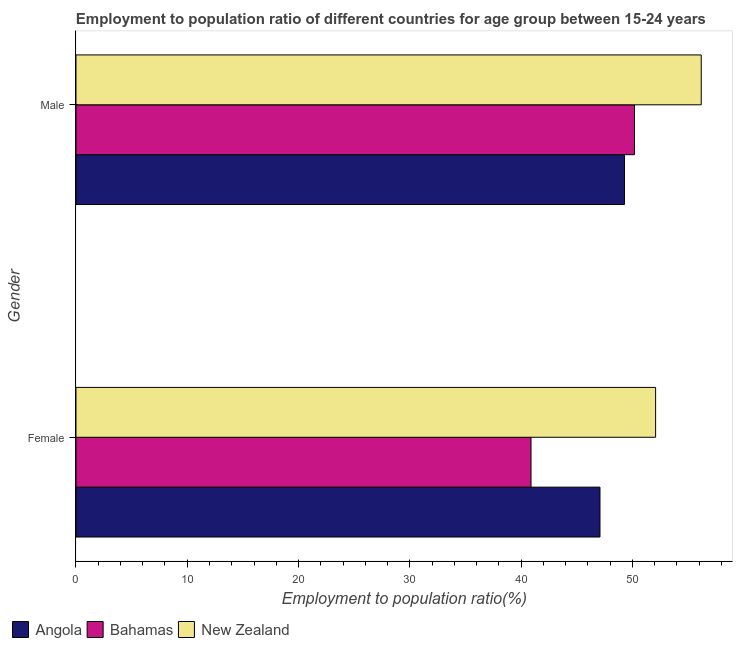How many different coloured bars are there?
Provide a succinct answer. 3. How many groups of bars are there?
Give a very brief answer. 2. How many bars are there on the 2nd tick from the bottom?
Make the answer very short. 3. What is the employment to population ratio(female) in Angola?
Give a very brief answer. 47.1. Across all countries, what is the maximum employment to population ratio(female)?
Ensure brevity in your answer.  52.1. Across all countries, what is the minimum employment to population ratio(female)?
Make the answer very short. 40.9. In which country was the employment to population ratio(female) maximum?
Your answer should be very brief. New Zealand. In which country was the employment to population ratio(male) minimum?
Keep it short and to the point. Angola. What is the total employment to population ratio(male) in the graph?
Make the answer very short. 155.7. What is the difference between the employment to population ratio(male) in New Zealand and the employment to population ratio(female) in Bahamas?
Offer a very short reply. 15.3. What is the average employment to population ratio(female) per country?
Your response must be concise. 46.7. What is the difference between the employment to population ratio(female) and employment to population ratio(male) in New Zealand?
Provide a succinct answer. -4.1. What is the ratio of the employment to population ratio(male) in Bahamas to that in New Zealand?
Offer a terse response. 0.89. Is the employment to population ratio(male) in Bahamas less than that in Angola?
Offer a terse response. No. What does the 3rd bar from the top in Female represents?
Ensure brevity in your answer.  Angola. What does the 1st bar from the bottom in Female represents?
Offer a terse response. Angola. Are all the bars in the graph horizontal?
Make the answer very short. Yes. Are the values on the major ticks of X-axis written in scientific E-notation?
Offer a terse response. No. How many legend labels are there?
Your answer should be compact. 3. What is the title of the graph?
Offer a very short reply. Employment to population ratio of different countries for age group between 15-24 years. What is the label or title of the X-axis?
Provide a succinct answer. Employment to population ratio(%). What is the label or title of the Y-axis?
Your answer should be compact. Gender. What is the Employment to population ratio(%) in Angola in Female?
Make the answer very short. 47.1. What is the Employment to population ratio(%) of Bahamas in Female?
Your answer should be very brief. 40.9. What is the Employment to population ratio(%) of New Zealand in Female?
Your answer should be very brief. 52.1. What is the Employment to population ratio(%) in Angola in Male?
Provide a succinct answer. 49.3. What is the Employment to population ratio(%) of Bahamas in Male?
Provide a succinct answer. 50.2. What is the Employment to population ratio(%) of New Zealand in Male?
Keep it short and to the point. 56.2. Across all Gender, what is the maximum Employment to population ratio(%) of Angola?
Your response must be concise. 49.3. Across all Gender, what is the maximum Employment to population ratio(%) of Bahamas?
Your answer should be very brief. 50.2. Across all Gender, what is the maximum Employment to population ratio(%) in New Zealand?
Offer a very short reply. 56.2. Across all Gender, what is the minimum Employment to population ratio(%) of Angola?
Offer a terse response. 47.1. Across all Gender, what is the minimum Employment to population ratio(%) in Bahamas?
Give a very brief answer. 40.9. Across all Gender, what is the minimum Employment to population ratio(%) in New Zealand?
Your response must be concise. 52.1. What is the total Employment to population ratio(%) in Angola in the graph?
Provide a succinct answer. 96.4. What is the total Employment to population ratio(%) in Bahamas in the graph?
Your response must be concise. 91.1. What is the total Employment to population ratio(%) in New Zealand in the graph?
Offer a terse response. 108.3. What is the difference between the Employment to population ratio(%) of Bahamas in Female and that in Male?
Your answer should be very brief. -9.3. What is the difference between the Employment to population ratio(%) in New Zealand in Female and that in Male?
Provide a short and direct response. -4.1. What is the difference between the Employment to population ratio(%) in Angola in Female and the Employment to population ratio(%) in Bahamas in Male?
Ensure brevity in your answer.  -3.1. What is the difference between the Employment to population ratio(%) in Angola in Female and the Employment to population ratio(%) in New Zealand in Male?
Make the answer very short. -9.1. What is the difference between the Employment to population ratio(%) in Bahamas in Female and the Employment to population ratio(%) in New Zealand in Male?
Give a very brief answer. -15.3. What is the average Employment to population ratio(%) in Angola per Gender?
Your answer should be very brief. 48.2. What is the average Employment to population ratio(%) in Bahamas per Gender?
Your answer should be very brief. 45.55. What is the average Employment to population ratio(%) in New Zealand per Gender?
Offer a very short reply. 54.15. What is the difference between the Employment to population ratio(%) of Angola and Employment to population ratio(%) of Bahamas in Female?
Keep it short and to the point. 6.2. What is the difference between the Employment to population ratio(%) in Angola and Employment to population ratio(%) in Bahamas in Male?
Your response must be concise. -0.9. What is the difference between the Employment to population ratio(%) of Angola and Employment to population ratio(%) of New Zealand in Male?
Make the answer very short. -6.9. What is the ratio of the Employment to population ratio(%) of Angola in Female to that in Male?
Ensure brevity in your answer.  0.96. What is the ratio of the Employment to population ratio(%) of Bahamas in Female to that in Male?
Offer a terse response. 0.81. What is the ratio of the Employment to population ratio(%) of New Zealand in Female to that in Male?
Provide a succinct answer. 0.93. What is the difference between the highest and the second highest Employment to population ratio(%) in Angola?
Make the answer very short. 2.2. What is the difference between the highest and the second highest Employment to population ratio(%) in Bahamas?
Keep it short and to the point. 9.3. What is the difference between the highest and the second highest Employment to population ratio(%) in New Zealand?
Ensure brevity in your answer.  4.1. What is the difference between the highest and the lowest Employment to population ratio(%) in New Zealand?
Ensure brevity in your answer.  4.1. 